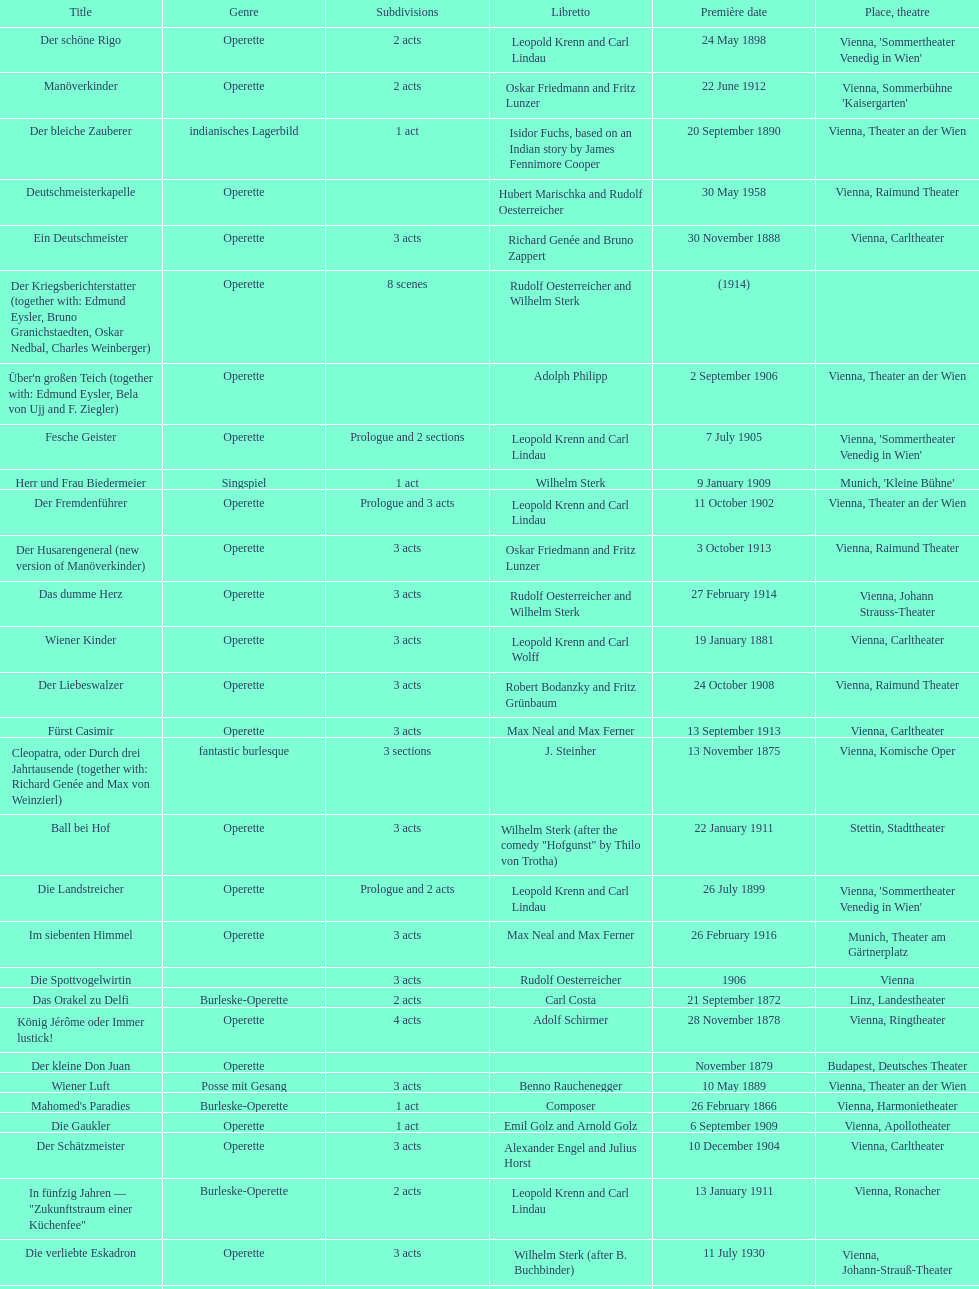In which city did the most operettas premiere? Vienna. 